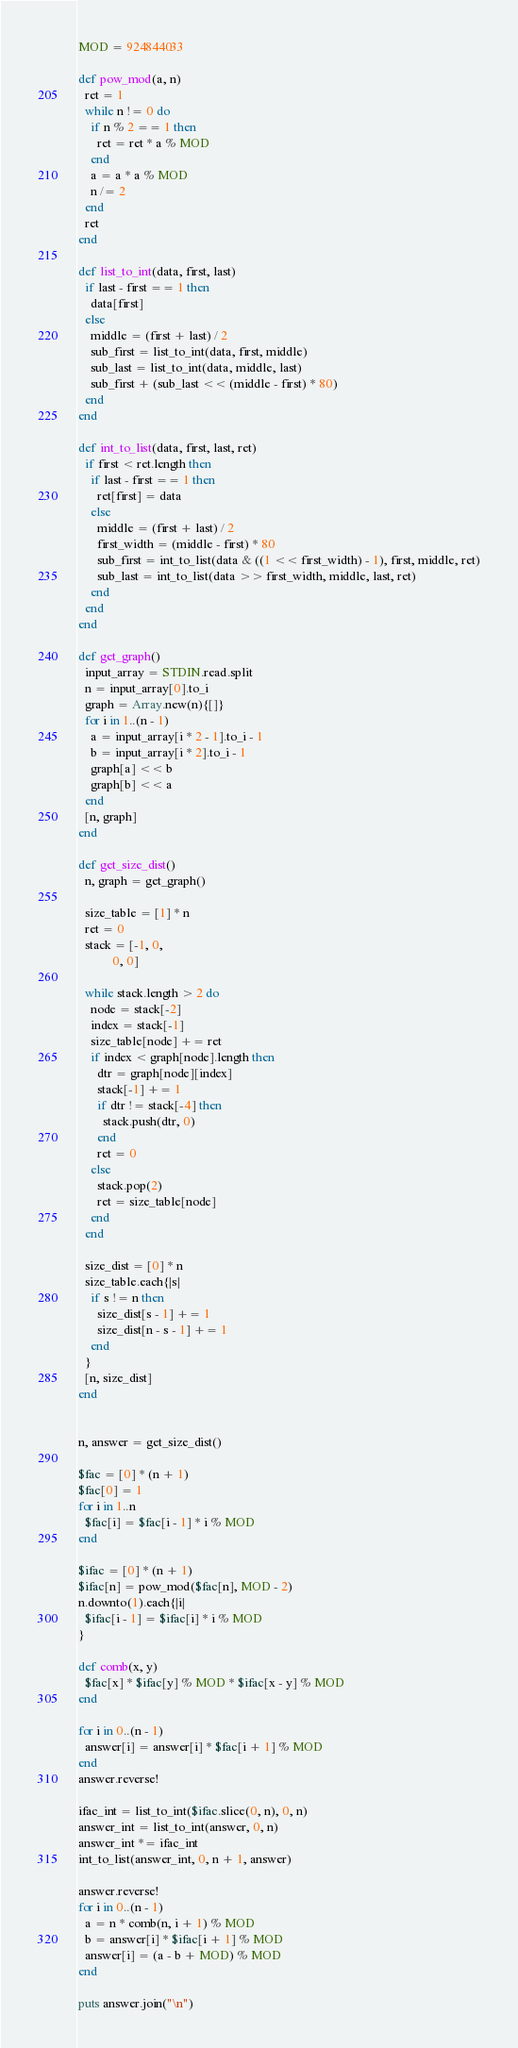Convert code to text. <code><loc_0><loc_0><loc_500><loc_500><_Ruby_>MOD = 924844033

def pow_mod(a, n)
  ret = 1
  while n != 0 do
    if n % 2 == 1 then
      ret = ret * a % MOD
    end
    a = a * a % MOD
    n /= 2
  end
  ret
end

def list_to_int(data, first, last)
  if last - first == 1 then
    data[first]
  else
    middle = (first + last) / 2
    sub_first = list_to_int(data, first, middle)
    sub_last = list_to_int(data, middle, last)
    sub_first + (sub_last << (middle - first) * 80)
  end
end

def int_to_list(data, first, last, ret)
  if first < ret.length then
    if last - first == 1 then
      ret[first] = data
    else
      middle = (first + last) / 2
      first_width = (middle - first) * 80
      sub_first = int_to_list(data & ((1 << first_width) - 1), first, middle, ret)
      sub_last = int_to_list(data >> first_width, middle, last, ret)
    end
  end
end

def get_graph()
  input_array = STDIN.read.split
  n = input_array[0].to_i
  graph = Array.new(n){[]}
  for i in 1..(n - 1)
    a = input_array[i * 2 - 1].to_i - 1
    b = input_array[i * 2].to_i - 1
    graph[a] << b
    graph[b] << a
  end
  [n, graph]
end

def get_size_dist()
  n, graph = get_graph()

  size_table = [1] * n
  ret = 0
  stack = [-1, 0,
           0, 0]

  while stack.length > 2 do
    node = stack[-2]
    index = stack[-1]
    size_table[node] += ret
    if index < graph[node].length then
      dtr = graph[node][index]
      stack[-1] += 1
      if dtr != stack[-4] then
        stack.push(dtr, 0)
      end
      ret = 0
    else
      stack.pop(2)
      ret = size_table[node]
    end
  end

  size_dist = [0] * n
  size_table.each{|s|
    if s != n then
      size_dist[s - 1] += 1
      size_dist[n - s - 1] += 1
    end
  }
  [n, size_dist]
end


n, answer = get_size_dist()

$fac = [0] * (n + 1)
$fac[0] = 1
for i in 1..n
  $fac[i] = $fac[i - 1] * i % MOD
end

$ifac = [0] * (n + 1)
$ifac[n] = pow_mod($fac[n], MOD - 2)
n.downto(1).each{|i|
  $ifac[i - 1] = $ifac[i] * i % MOD
}

def comb(x, y)
  $fac[x] * $ifac[y] % MOD * $ifac[x - y] % MOD
end

for i in 0..(n - 1)
  answer[i] = answer[i] * $fac[i + 1] % MOD
end
answer.reverse!

ifac_int = list_to_int($ifac.slice(0, n), 0, n)
answer_int = list_to_int(answer, 0, n)
answer_int *= ifac_int
int_to_list(answer_int, 0, n + 1, answer)

answer.reverse!
for i in 0..(n - 1)
  a = n * comb(n, i + 1) % MOD
  b = answer[i] * $ifac[i + 1] % MOD
  answer[i] = (a - b + MOD) % MOD
end

puts answer.join("\n")
</code> 